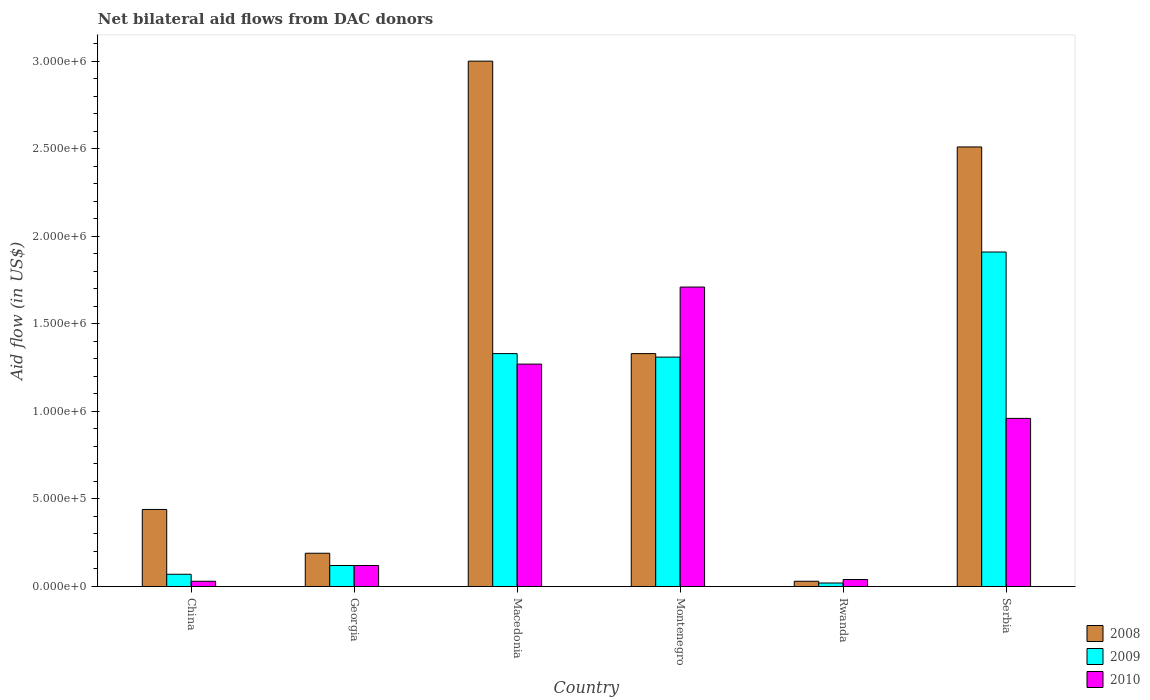How many groups of bars are there?
Provide a short and direct response. 6. Are the number of bars on each tick of the X-axis equal?
Offer a terse response. Yes. How many bars are there on the 1st tick from the left?
Give a very brief answer. 3. What is the label of the 2nd group of bars from the left?
Ensure brevity in your answer.  Georgia. In how many cases, is the number of bars for a given country not equal to the number of legend labels?
Keep it short and to the point. 0. What is the net bilateral aid flow in 2010 in Rwanda?
Offer a terse response. 4.00e+04. Across all countries, what is the maximum net bilateral aid flow in 2009?
Your response must be concise. 1.91e+06. Across all countries, what is the minimum net bilateral aid flow in 2010?
Offer a terse response. 3.00e+04. In which country was the net bilateral aid flow in 2008 maximum?
Provide a short and direct response. Macedonia. In which country was the net bilateral aid flow in 2009 minimum?
Ensure brevity in your answer.  Rwanda. What is the total net bilateral aid flow in 2008 in the graph?
Your answer should be compact. 7.50e+06. What is the difference between the net bilateral aid flow in 2008 in Macedonia and the net bilateral aid flow in 2009 in China?
Give a very brief answer. 2.93e+06. What is the average net bilateral aid flow in 2010 per country?
Provide a succinct answer. 6.88e+05. In how many countries, is the net bilateral aid flow in 2009 greater than 1100000 US$?
Your answer should be compact. 3. What is the ratio of the net bilateral aid flow in 2009 in Montenegro to that in Rwanda?
Your answer should be compact. 65.5. Is the net bilateral aid flow in 2009 in China less than that in Rwanda?
Ensure brevity in your answer.  No. Is the difference between the net bilateral aid flow in 2008 in China and Serbia greater than the difference between the net bilateral aid flow in 2010 in China and Serbia?
Make the answer very short. No. What is the difference between the highest and the second highest net bilateral aid flow in 2010?
Offer a very short reply. 4.40e+05. What is the difference between the highest and the lowest net bilateral aid flow in 2009?
Keep it short and to the point. 1.89e+06. Is the sum of the net bilateral aid flow in 2010 in Georgia and Rwanda greater than the maximum net bilateral aid flow in 2008 across all countries?
Your answer should be compact. No. What does the 1st bar from the left in Georgia represents?
Offer a very short reply. 2008. What does the 2nd bar from the right in China represents?
Your response must be concise. 2009. Is it the case that in every country, the sum of the net bilateral aid flow in 2008 and net bilateral aid flow in 2009 is greater than the net bilateral aid flow in 2010?
Provide a succinct answer. Yes. How many bars are there?
Provide a short and direct response. 18. How many countries are there in the graph?
Offer a terse response. 6. What is the difference between two consecutive major ticks on the Y-axis?
Your answer should be very brief. 5.00e+05. Are the values on the major ticks of Y-axis written in scientific E-notation?
Your answer should be compact. Yes. Does the graph contain grids?
Your response must be concise. No. How are the legend labels stacked?
Your response must be concise. Vertical. What is the title of the graph?
Your answer should be very brief. Net bilateral aid flows from DAC donors. Does "1960" appear as one of the legend labels in the graph?
Keep it short and to the point. No. What is the label or title of the X-axis?
Keep it short and to the point. Country. What is the label or title of the Y-axis?
Ensure brevity in your answer.  Aid flow (in US$). What is the Aid flow (in US$) in 2008 in China?
Ensure brevity in your answer.  4.40e+05. What is the Aid flow (in US$) of 2009 in China?
Your answer should be very brief. 7.00e+04. What is the Aid flow (in US$) in 2010 in China?
Provide a succinct answer. 3.00e+04. What is the Aid flow (in US$) in 2008 in Georgia?
Provide a succinct answer. 1.90e+05. What is the Aid flow (in US$) of 2009 in Macedonia?
Provide a short and direct response. 1.33e+06. What is the Aid flow (in US$) of 2010 in Macedonia?
Offer a very short reply. 1.27e+06. What is the Aid flow (in US$) in 2008 in Montenegro?
Ensure brevity in your answer.  1.33e+06. What is the Aid flow (in US$) of 2009 in Montenegro?
Your answer should be very brief. 1.31e+06. What is the Aid flow (in US$) of 2010 in Montenegro?
Offer a very short reply. 1.71e+06. What is the Aid flow (in US$) in 2009 in Rwanda?
Offer a very short reply. 2.00e+04. What is the Aid flow (in US$) of 2010 in Rwanda?
Make the answer very short. 4.00e+04. What is the Aid flow (in US$) of 2008 in Serbia?
Offer a very short reply. 2.51e+06. What is the Aid flow (in US$) of 2009 in Serbia?
Keep it short and to the point. 1.91e+06. What is the Aid flow (in US$) in 2010 in Serbia?
Make the answer very short. 9.60e+05. Across all countries, what is the maximum Aid flow (in US$) of 2009?
Your response must be concise. 1.91e+06. Across all countries, what is the maximum Aid flow (in US$) of 2010?
Your response must be concise. 1.71e+06. Across all countries, what is the minimum Aid flow (in US$) in 2009?
Your response must be concise. 2.00e+04. What is the total Aid flow (in US$) in 2008 in the graph?
Your response must be concise. 7.50e+06. What is the total Aid flow (in US$) in 2009 in the graph?
Make the answer very short. 4.76e+06. What is the total Aid flow (in US$) of 2010 in the graph?
Give a very brief answer. 4.13e+06. What is the difference between the Aid flow (in US$) in 2008 in China and that in Georgia?
Make the answer very short. 2.50e+05. What is the difference between the Aid flow (in US$) of 2009 in China and that in Georgia?
Ensure brevity in your answer.  -5.00e+04. What is the difference between the Aid flow (in US$) of 2008 in China and that in Macedonia?
Give a very brief answer. -2.56e+06. What is the difference between the Aid flow (in US$) in 2009 in China and that in Macedonia?
Provide a succinct answer. -1.26e+06. What is the difference between the Aid flow (in US$) in 2010 in China and that in Macedonia?
Provide a short and direct response. -1.24e+06. What is the difference between the Aid flow (in US$) of 2008 in China and that in Montenegro?
Make the answer very short. -8.90e+05. What is the difference between the Aid flow (in US$) in 2009 in China and that in Montenegro?
Provide a short and direct response. -1.24e+06. What is the difference between the Aid flow (in US$) in 2010 in China and that in Montenegro?
Make the answer very short. -1.68e+06. What is the difference between the Aid flow (in US$) in 2008 in China and that in Rwanda?
Offer a terse response. 4.10e+05. What is the difference between the Aid flow (in US$) in 2009 in China and that in Rwanda?
Ensure brevity in your answer.  5.00e+04. What is the difference between the Aid flow (in US$) of 2010 in China and that in Rwanda?
Make the answer very short. -10000. What is the difference between the Aid flow (in US$) of 2008 in China and that in Serbia?
Ensure brevity in your answer.  -2.07e+06. What is the difference between the Aid flow (in US$) of 2009 in China and that in Serbia?
Offer a very short reply. -1.84e+06. What is the difference between the Aid flow (in US$) in 2010 in China and that in Serbia?
Give a very brief answer. -9.30e+05. What is the difference between the Aid flow (in US$) of 2008 in Georgia and that in Macedonia?
Your answer should be very brief. -2.81e+06. What is the difference between the Aid flow (in US$) of 2009 in Georgia and that in Macedonia?
Your answer should be very brief. -1.21e+06. What is the difference between the Aid flow (in US$) in 2010 in Georgia and that in Macedonia?
Your answer should be compact. -1.15e+06. What is the difference between the Aid flow (in US$) of 2008 in Georgia and that in Montenegro?
Keep it short and to the point. -1.14e+06. What is the difference between the Aid flow (in US$) in 2009 in Georgia and that in Montenegro?
Offer a terse response. -1.19e+06. What is the difference between the Aid flow (in US$) of 2010 in Georgia and that in Montenegro?
Give a very brief answer. -1.59e+06. What is the difference between the Aid flow (in US$) in 2008 in Georgia and that in Rwanda?
Your answer should be very brief. 1.60e+05. What is the difference between the Aid flow (in US$) of 2010 in Georgia and that in Rwanda?
Keep it short and to the point. 8.00e+04. What is the difference between the Aid flow (in US$) in 2008 in Georgia and that in Serbia?
Your response must be concise. -2.32e+06. What is the difference between the Aid flow (in US$) in 2009 in Georgia and that in Serbia?
Offer a terse response. -1.79e+06. What is the difference between the Aid flow (in US$) of 2010 in Georgia and that in Serbia?
Offer a terse response. -8.40e+05. What is the difference between the Aid flow (in US$) of 2008 in Macedonia and that in Montenegro?
Ensure brevity in your answer.  1.67e+06. What is the difference between the Aid flow (in US$) in 2010 in Macedonia and that in Montenegro?
Provide a succinct answer. -4.40e+05. What is the difference between the Aid flow (in US$) in 2008 in Macedonia and that in Rwanda?
Your response must be concise. 2.97e+06. What is the difference between the Aid flow (in US$) in 2009 in Macedonia and that in Rwanda?
Make the answer very short. 1.31e+06. What is the difference between the Aid flow (in US$) in 2010 in Macedonia and that in Rwanda?
Make the answer very short. 1.23e+06. What is the difference between the Aid flow (in US$) of 2009 in Macedonia and that in Serbia?
Keep it short and to the point. -5.80e+05. What is the difference between the Aid flow (in US$) of 2008 in Montenegro and that in Rwanda?
Ensure brevity in your answer.  1.30e+06. What is the difference between the Aid flow (in US$) of 2009 in Montenegro and that in Rwanda?
Your response must be concise. 1.29e+06. What is the difference between the Aid flow (in US$) in 2010 in Montenegro and that in Rwanda?
Offer a very short reply. 1.67e+06. What is the difference between the Aid flow (in US$) of 2008 in Montenegro and that in Serbia?
Your answer should be compact. -1.18e+06. What is the difference between the Aid flow (in US$) in 2009 in Montenegro and that in Serbia?
Give a very brief answer. -6.00e+05. What is the difference between the Aid flow (in US$) in 2010 in Montenegro and that in Serbia?
Give a very brief answer. 7.50e+05. What is the difference between the Aid flow (in US$) in 2008 in Rwanda and that in Serbia?
Make the answer very short. -2.48e+06. What is the difference between the Aid flow (in US$) of 2009 in Rwanda and that in Serbia?
Offer a terse response. -1.89e+06. What is the difference between the Aid flow (in US$) in 2010 in Rwanda and that in Serbia?
Keep it short and to the point. -9.20e+05. What is the difference between the Aid flow (in US$) of 2008 in China and the Aid flow (in US$) of 2009 in Macedonia?
Provide a succinct answer. -8.90e+05. What is the difference between the Aid flow (in US$) of 2008 in China and the Aid flow (in US$) of 2010 in Macedonia?
Ensure brevity in your answer.  -8.30e+05. What is the difference between the Aid flow (in US$) of 2009 in China and the Aid flow (in US$) of 2010 in Macedonia?
Ensure brevity in your answer.  -1.20e+06. What is the difference between the Aid flow (in US$) in 2008 in China and the Aid flow (in US$) in 2009 in Montenegro?
Offer a very short reply. -8.70e+05. What is the difference between the Aid flow (in US$) of 2008 in China and the Aid flow (in US$) of 2010 in Montenegro?
Provide a short and direct response. -1.27e+06. What is the difference between the Aid flow (in US$) of 2009 in China and the Aid flow (in US$) of 2010 in Montenegro?
Provide a short and direct response. -1.64e+06. What is the difference between the Aid flow (in US$) in 2008 in China and the Aid flow (in US$) in 2010 in Rwanda?
Give a very brief answer. 4.00e+05. What is the difference between the Aid flow (in US$) in 2008 in China and the Aid flow (in US$) in 2009 in Serbia?
Your answer should be very brief. -1.47e+06. What is the difference between the Aid flow (in US$) of 2008 in China and the Aid flow (in US$) of 2010 in Serbia?
Your response must be concise. -5.20e+05. What is the difference between the Aid flow (in US$) of 2009 in China and the Aid flow (in US$) of 2010 in Serbia?
Ensure brevity in your answer.  -8.90e+05. What is the difference between the Aid flow (in US$) of 2008 in Georgia and the Aid flow (in US$) of 2009 in Macedonia?
Offer a very short reply. -1.14e+06. What is the difference between the Aid flow (in US$) of 2008 in Georgia and the Aid flow (in US$) of 2010 in Macedonia?
Ensure brevity in your answer.  -1.08e+06. What is the difference between the Aid flow (in US$) in 2009 in Georgia and the Aid flow (in US$) in 2010 in Macedonia?
Offer a very short reply. -1.15e+06. What is the difference between the Aid flow (in US$) of 2008 in Georgia and the Aid flow (in US$) of 2009 in Montenegro?
Your answer should be very brief. -1.12e+06. What is the difference between the Aid flow (in US$) of 2008 in Georgia and the Aid flow (in US$) of 2010 in Montenegro?
Give a very brief answer. -1.52e+06. What is the difference between the Aid flow (in US$) of 2009 in Georgia and the Aid flow (in US$) of 2010 in Montenegro?
Offer a very short reply. -1.59e+06. What is the difference between the Aid flow (in US$) of 2008 in Georgia and the Aid flow (in US$) of 2009 in Serbia?
Your answer should be very brief. -1.72e+06. What is the difference between the Aid flow (in US$) of 2008 in Georgia and the Aid flow (in US$) of 2010 in Serbia?
Give a very brief answer. -7.70e+05. What is the difference between the Aid flow (in US$) of 2009 in Georgia and the Aid flow (in US$) of 2010 in Serbia?
Ensure brevity in your answer.  -8.40e+05. What is the difference between the Aid flow (in US$) in 2008 in Macedonia and the Aid flow (in US$) in 2009 in Montenegro?
Make the answer very short. 1.69e+06. What is the difference between the Aid flow (in US$) of 2008 in Macedonia and the Aid flow (in US$) of 2010 in Montenegro?
Your answer should be very brief. 1.29e+06. What is the difference between the Aid flow (in US$) of 2009 in Macedonia and the Aid flow (in US$) of 2010 in Montenegro?
Make the answer very short. -3.80e+05. What is the difference between the Aid flow (in US$) of 2008 in Macedonia and the Aid flow (in US$) of 2009 in Rwanda?
Offer a very short reply. 2.98e+06. What is the difference between the Aid flow (in US$) in 2008 in Macedonia and the Aid flow (in US$) in 2010 in Rwanda?
Keep it short and to the point. 2.96e+06. What is the difference between the Aid flow (in US$) of 2009 in Macedonia and the Aid flow (in US$) of 2010 in Rwanda?
Your answer should be very brief. 1.29e+06. What is the difference between the Aid flow (in US$) of 2008 in Macedonia and the Aid flow (in US$) of 2009 in Serbia?
Give a very brief answer. 1.09e+06. What is the difference between the Aid flow (in US$) of 2008 in Macedonia and the Aid flow (in US$) of 2010 in Serbia?
Your answer should be compact. 2.04e+06. What is the difference between the Aid flow (in US$) in 2008 in Montenegro and the Aid flow (in US$) in 2009 in Rwanda?
Ensure brevity in your answer.  1.31e+06. What is the difference between the Aid flow (in US$) in 2008 in Montenegro and the Aid flow (in US$) in 2010 in Rwanda?
Your response must be concise. 1.29e+06. What is the difference between the Aid flow (in US$) in 2009 in Montenegro and the Aid flow (in US$) in 2010 in Rwanda?
Offer a terse response. 1.27e+06. What is the difference between the Aid flow (in US$) in 2008 in Montenegro and the Aid flow (in US$) in 2009 in Serbia?
Your answer should be very brief. -5.80e+05. What is the difference between the Aid flow (in US$) in 2008 in Rwanda and the Aid flow (in US$) in 2009 in Serbia?
Your response must be concise. -1.88e+06. What is the difference between the Aid flow (in US$) of 2008 in Rwanda and the Aid flow (in US$) of 2010 in Serbia?
Your answer should be very brief. -9.30e+05. What is the difference between the Aid flow (in US$) in 2009 in Rwanda and the Aid flow (in US$) in 2010 in Serbia?
Make the answer very short. -9.40e+05. What is the average Aid flow (in US$) of 2008 per country?
Provide a short and direct response. 1.25e+06. What is the average Aid flow (in US$) in 2009 per country?
Your response must be concise. 7.93e+05. What is the average Aid flow (in US$) in 2010 per country?
Offer a very short reply. 6.88e+05. What is the difference between the Aid flow (in US$) of 2008 and Aid flow (in US$) of 2009 in Georgia?
Your answer should be compact. 7.00e+04. What is the difference between the Aid flow (in US$) of 2008 and Aid flow (in US$) of 2009 in Macedonia?
Your answer should be very brief. 1.67e+06. What is the difference between the Aid flow (in US$) in 2008 and Aid flow (in US$) in 2010 in Macedonia?
Your answer should be very brief. 1.73e+06. What is the difference between the Aid flow (in US$) of 2008 and Aid flow (in US$) of 2009 in Montenegro?
Your response must be concise. 2.00e+04. What is the difference between the Aid flow (in US$) of 2008 and Aid flow (in US$) of 2010 in Montenegro?
Your response must be concise. -3.80e+05. What is the difference between the Aid flow (in US$) in 2009 and Aid flow (in US$) in 2010 in Montenegro?
Offer a very short reply. -4.00e+05. What is the difference between the Aid flow (in US$) of 2009 and Aid flow (in US$) of 2010 in Rwanda?
Ensure brevity in your answer.  -2.00e+04. What is the difference between the Aid flow (in US$) of 2008 and Aid flow (in US$) of 2010 in Serbia?
Give a very brief answer. 1.55e+06. What is the difference between the Aid flow (in US$) of 2009 and Aid flow (in US$) of 2010 in Serbia?
Provide a succinct answer. 9.50e+05. What is the ratio of the Aid flow (in US$) in 2008 in China to that in Georgia?
Keep it short and to the point. 2.32. What is the ratio of the Aid flow (in US$) in 2009 in China to that in Georgia?
Your response must be concise. 0.58. What is the ratio of the Aid flow (in US$) of 2010 in China to that in Georgia?
Your answer should be very brief. 0.25. What is the ratio of the Aid flow (in US$) in 2008 in China to that in Macedonia?
Make the answer very short. 0.15. What is the ratio of the Aid flow (in US$) of 2009 in China to that in Macedonia?
Offer a very short reply. 0.05. What is the ratio of the Aid flow (in US$) in 2010 in China to that in Macedonia?
Your answer should be very brief. 0.02. What is the ratio of the Aid flow (in US$) in 2008 in China to that in Montenegro?
Give a very brief answer. 0.33. What is the ratio of the Aid flow (in US$) in 2009 in China to that in Montenegro?
Your answer should be very brief. 0.05. What is the ratio of the Aid flow (in US$) of 2010 in China to that in Montenegro?
Offer a very short reply. 0.02. What is the ratio of the Aid flow (in US$) of 2008 in China to that in Rwanda?
Offer a very short reply. 14.67. What is the ratio of the Aid flow (in US$) of 2008 in China to that in Serbia?
Your answer should be compact. 0.18. What is the ratio of the Aid flow (in US$) in 2009 in China to that in Serbia?
Offer a terse response. 0.04. What is the ratio of the Aid flow (in US$) in 2010 in China to that in Serbia?
Provide a short and direct response. 0.03. What is the ratio of the Aid flow (in US$) in 2008 in Georgia to that in Macedonia?
Provide a succinct answer. 0.06. What is the ratio of the Aid flow (in US$) of 2009 in Georgia to that in Macedonia?
Keep it short and to the point. 0.09. What is the ratio of the Aid flow (in US$) of 2010 in Georgia to that in Macedonia?
Your answer should be very brief. 0.09. What is the ratio of the Aid flow (in US$) of 2008 in Georgia to that in Montenegro?
Provide a short and direct response. 0.14. What is the ratio of the Aid flow (in US$) in 2009 in Georgia to that in Montenegro?
Offer a terse response. 0.09. What is the ratio of the Aid flow (in US$) of 2010 in Georgia to that in Montenegro?
Your answer should be very brief. 0.07. What is the ratio of the Aid flow (in US$) in 2008 in Georgia to that in Rwanda?
Make the answer very short. 6.33. What is the ratio of the Aid flow (in US$) in 2008 in Georgia to that in Serbia?
Provide a succinct answer. 0.08. What is the ratio of the Aid flow (in US$) in 2009 in Georgia to that in Serbia?
Offer a very short reply. 0.06. What is the ratio of the Aid flow (in US$) of 2010 in Georgia to that in Serbia?
Provide a short and direct response. 0.12. What is the ratio of the Aid flow (in US$) of 2008 in Macedonia to that in Montenegro?
Make the answer very short. 2.26. What is the ratio of the Aid flow (in US$) of 2009 in Macedonia to that in Montenegro?
Provide a short and direct response. 1.02. What is the ratio of the Aid flow (in US$) of 2010 in Macedonia to that in Montenegro?
Your answer should be compact. 0.74. What is the ratio of the Aid flow (in US$) in 2008 in Macedonia to that in Rwanda?
Provide a short and direct response. 100. What is the ratio of the Aid flow (in US$) of 2009 in Macedonia to that in Rwanda?
Offer a very short reply. 66.5. What is the ratio of the Aid flow (in US$) in 2010 in Macedonia to that in Rwanda?
Give a very brief answer. 31.75. What is the ratio of the Aid flow (in US$) in 2008 in Macedonia to that in Serbia?
Ensure brevity in your answer.  1.2. What is the ratio of the Aid flow (in US$) in 2009 in Macedonia to that in Serbia?
Keep it short and to the point. 0.7. What is the ratio of the Aid flow (in US$) in 2010 in Macedonia to that in Serbia?
Give a very brief answer. 1.32. What is the ratio of the Aid flow (in US$) of 2008 in Montenegro to that in Rwanda?
Make the answer very short. 44.33. What is the ratio of the Aid flow (in US$) of 2009 in Montenegro to that in Rwanda?
Offer a terse response. 65.5. What is the ratio of the Aid flow (in US$) in 2010 in Montenegro to that in Rwanda?
Give a very brief answer. 42.75. What is the ratio of the Aid flow (in US$) of 2008 in Montenegro to that in Serbia?
Offer a terse response. 0.53. What is the ratio of the Aid flow (in US$) of 2009 in Montenegro to that in Serbia?
Make the answer very short. 0.69. What is the ratio of the Aid flow (in US$) in 2010 in Montenegro to that in Serbia?
Offer a terse response. 1.78. What is the ratio of the Aid flow (in US$) of 2008 in Rwanda to that in Serbia?
Offer a terse response. 0.01. What is the ratio of the Aid flow (in US$) in 2009 in Rwanda to that in Serbia?
Ensure brevity in your answer.  0.01. What is the ratio of the Aid flow (in US$) in 2010 in Rwanda to that in Serbia?
Your answer should be compact. 0.04. What is the difference between the highest and the second highest Aid flow (in US$) of 2009?
Keep it short and to the point. 5.80e+05. What is the difference between the highest and the lowest Aid flow (in US$) in 2008?
Give a very brief answer. 2.97e+06. What is the difference between the highest and the lowest Aid flow (in US$) in 2009?
Provide a succinct answer. 1.89e+06. What is the difference between the highest and the lowest Aid flow (in US$) in 2010?
Your answer should be very brief. 1.68e+06. 